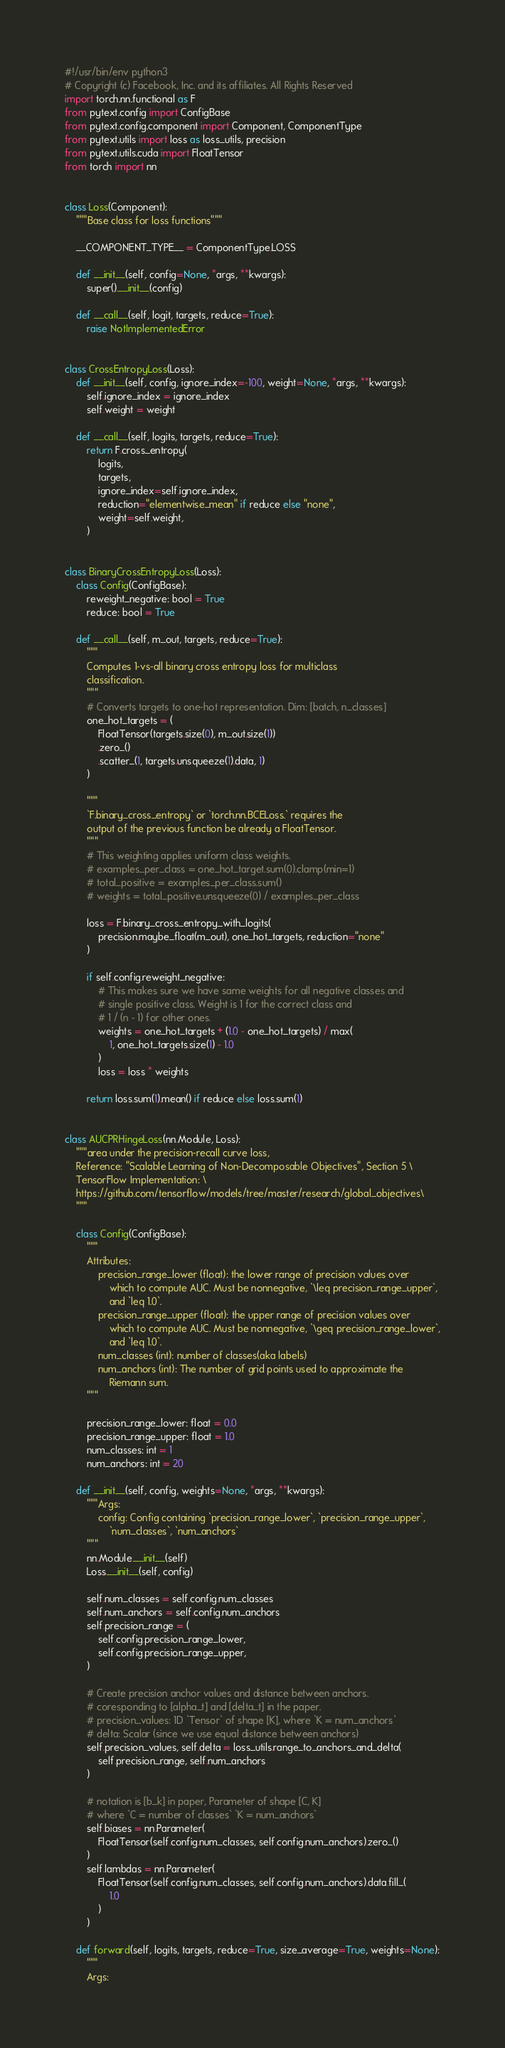Convert code to text. <code><loc_0><loc_0><loc_500><loc_500><_Python_>#!/usr/bin/env python3
# Copyright (c) Facebook, Inc. and its affiliates. All Rights Reserved
import torch.nn.functional as F
from pytext.config import ConfigBase
from pytext.config.component import Component, ComponentType
from pytext.utils import loss as loss_utils, precision
from pytext.utils.cuda import FloatTensor
from torch import nn


class Loss(Component):
    """Base class for loss functions"""

    __COMPONENT_TYPE__ = ComponentType.LOSS

    def __init__(self, config=None, *args, **kwargs):
        super().__init__(config)

    def __call__(self, logit, targets, reduce=True):
        raise NotImplementedError


class CrossEntropyLoss(Loss):
    def __init__(self, config, ignore_index=-100, weight=None, *args, **kwargs):
        self.ignore_index = ignore_index
        self.weight = weight

    def __call__(self, logits, targets, reduce=True):
        return F.cross_entropy(
            logits,
            targets,
            ignore_index=self.ignore_index,
            reduction="elementwise_mean" if reduce else "none",
            weight=self.weight,
        )


class BinaryCrossEntropyLoss(Loss):
    class Config(ConfigBase):
        reweight_negative: bool = True
        reduce: bool = True

    def __call__(self, m_out, targets, reduce=True):
        """
        Computes 1-vs-all binary cross entropy loss for multiclass
        classification.
        """
        # Converts targets to one-hot representation. Dim: [batch, n_classes]
        one_hot_targets = (
            FloatTensor(targets.size(0), m_out.size(1))
            .zero_()
            .scatter_(1, targets.unsqueeze(1).data, 1)
        )

        """
        `F.binary_cross_entropy` or `torch.nn.BCELoss.` requires the
        output of the previous function be already a FloatTensor.
        """
        # This weighting applies uniform class weights.
        # examples_per_class = one_hot_target.sum(0).clamp(min=1)
        # total_positive = examples_per_class.sum()
        # weights = total_positive.unsqueeze(0) / examples_per_class

        loss = F.binary_cross_entropy_with_logits(
            precision.maybe_float(m_out), one_hot_targets, reduction="none"
        )

        if self.config.reweight_negative:
            # This makes sure we have same weights for all negative classes and
            # single positive class. Weight is 1 for the correct class and
            # 1 / (n - 1) for other ones.
            weights = one_hot_targets + (1.0 - one_hot_targets) / max(
                1, one_hot_targets.size(1) - 1.0
            )
            loss = loss * weights

        return loss.sum(1).mean() if reduce else loss.sum(1)


class AUCPRHingeLoss(nn.Module, Loss):
    """area under the precision-recall curve loss,
    Reference: "Scalable Learning of Non-Decomposable Objectives", Section 5 \
    TensorFlow Implementation: \
    https://github.com/tensorflow/models/tree/master/research/global_objectives\
    """

    class Config(ConfigBase):
        """
        Attributes:
            precision_range_lower (float): the lower range of precision values over
                which to compute AUC. Must be nonnegative, `\leq precision_range_upper`,
                and `leq 1.0`.
            precision_range_upper (float): the upper range of precision values over
                which to compute AUC. Must be nonnegative, `\geq precision_range_lower`,
                and `leq 1.0`.
            num_classes (int): number of classes(aka labels)
            num_anchors (int): The number of grid points used to approximate the
                Riemann sum.
        """

        precision_range_lower: float = 0.0
        precision_range_upper: float = 1.0
        num_classes: int = 1
        num_anchors: int = 20

    def __init__(self, config, weights=None, *args, **kwargs):
        """Args:
            config: Config containing `precision_range_lower`, `precision_range_upper`,
                `num_classes`, `num_anchors`
        """
        nn.Module.__init__(self)
        Loss.__init__(self, config)

        self.num_classes = self.config.num_classes
        self.num_anchors = self.config.num_anchors
        self.precision_range = (
            self.config.precision_range_lower,
            self.config.precision_range_upper,
        )

        # Create precision anchor values and distance between anchors.
        # coresponding to [alpha_t] and [delta_t] in the paper.
        # precision_values: 1D `Tensor` of shape [K], where `K = num_anchors`
        # delta: Scalar (since we use equal distance between anchors)
        self.precision_values, self.delta = loss_utils.range_to_anchors_and_delta(
            self.precision_range, self.num_anchors
        )

        # notation is [b_k] in paper, Parameter of shape [C, K]
        # where `C = number of classes` `K = num_anchors`
        self.biases = nn.Parameter(
            FloatTensor(self.config.num_classes, self.config.num_anchors).zero_()
        )
        self.lambdas = nn.Parameter(
            FloatTensor(self.config.num_classes, self.config.num_anchors).data.fill_(
                1.0
            )
        )

    def forward(self, logits, targets, reduce=True, size_average=True, weights=None):
        """
        Args:</code> 